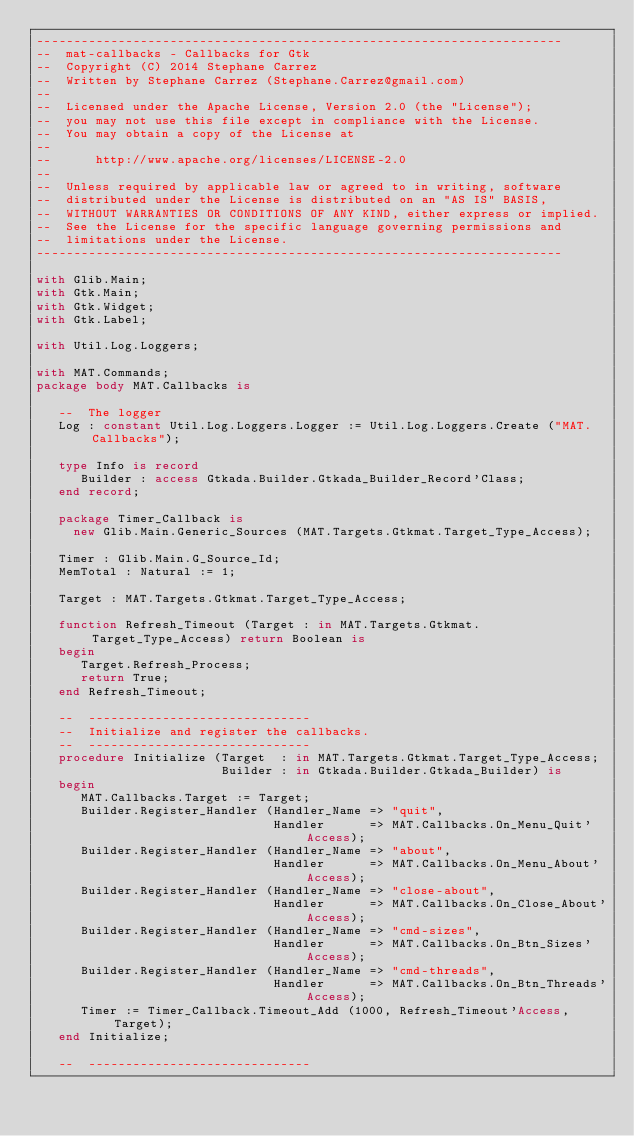<code> <loc_0><loc_0><loc_500><loc_500><_Ada_>-----------------------------------------------------------------------
--  mat-callbacks - Callbacks for Gtk
--  Copyright (C) 2014 Stephane Carrez
--  Written by Stephane Carrez (Stephane.Carrez@gmail.com)
--
--  Licensed under the Apache License, Version 2.0 (the "License");
--  you may not use this file except in compliance with the License.
--  You may obtain a copy of the License at
--
--      http://www.apache.org/licenses/LICENSE-2.0
--
--  Unless required by applicable law or agreed to in writing, software
--  distributed under the License is distributed on an "AS IS" BASIS,
--  WITHOUT WARRANTIES OR CONDITIONS OF ANY KIND, either express or implied.
--  See the License for the specific language governing permissions and
--  limitations under the License.
-----------------------------------------------------------------------

with Glib.Main;
with Gtk.Main;
with Gtk.Widget;
with Gtk.Label;

with Util.Log.Loggers;

with MAT.Commands;
package body MAT.Callbacks is

   --  The logger
   Log : constant Util.Log.Loggers.Logger := Util.Log.Loggers.Create ("MAT.Callbacks");

   type Info is record
      Builder : access Gtkada.Builder.Gtkada_Builder_Record'Class;
   end record;

   package Timer_Callback is
     new Glib.Main.Generic_Sources (MAT.Targets.Gtkmat.Target_Type_Access);

   Timer : Glib.Main.G_Source_Id;
   MemTotal : Natural := 1;

   Target : MAT.Targets.Gtkmat.Target_Type_Access;

   function Refresh_Timeout (Target : in MAT.Targets.Gtkmat.Target_Type_Access) return Boolean is
   begin
      Target.Refresh_Process;
      return True;
   end Refresh_Timeout;

   --  ------------------------------
   --  Initialize and register the callbacks.
   --  ------------------------------
   procedure Initialize (Target  : in MAT.Targets.Gtkmat.Target_Type_Access;
                         Builder : in Gtkada.Builder.Gtkada_Builder) is
   begin
      MAT.Callbacks.Target := Target;
      Builder.Register_Handler (Handler_Name => "quit",
                                Handler      => MAT.Callbacks.On_Menu_Quit'Access);
      Builder.Register_Handler (Handler_Name => "about",
                                Handler      => MAT.Callbacks.On_Menu_About'Access);
      Builder.Register_Handler (Handler_Name => "close-about",
                                Handler      => MAT.Callbacks.On_Close_About'Access);
      Builder.Register_Handler (Handler_Name => "cmd-sizes",
                                Handler      => MAT.Callbacks.On_Btn_Sizes'Access);
      Builder.Register_Handler (Handler_Name => "cmd-threads",
                                Handler      => MAT.Callbacks.On_Btn_Threads'Access);
      Timer := Timer_Callback.Timeout_Add (1000, Refresh_Timeout'Access, Target);
   end Initialize;

   --  ------------------------------</code> 